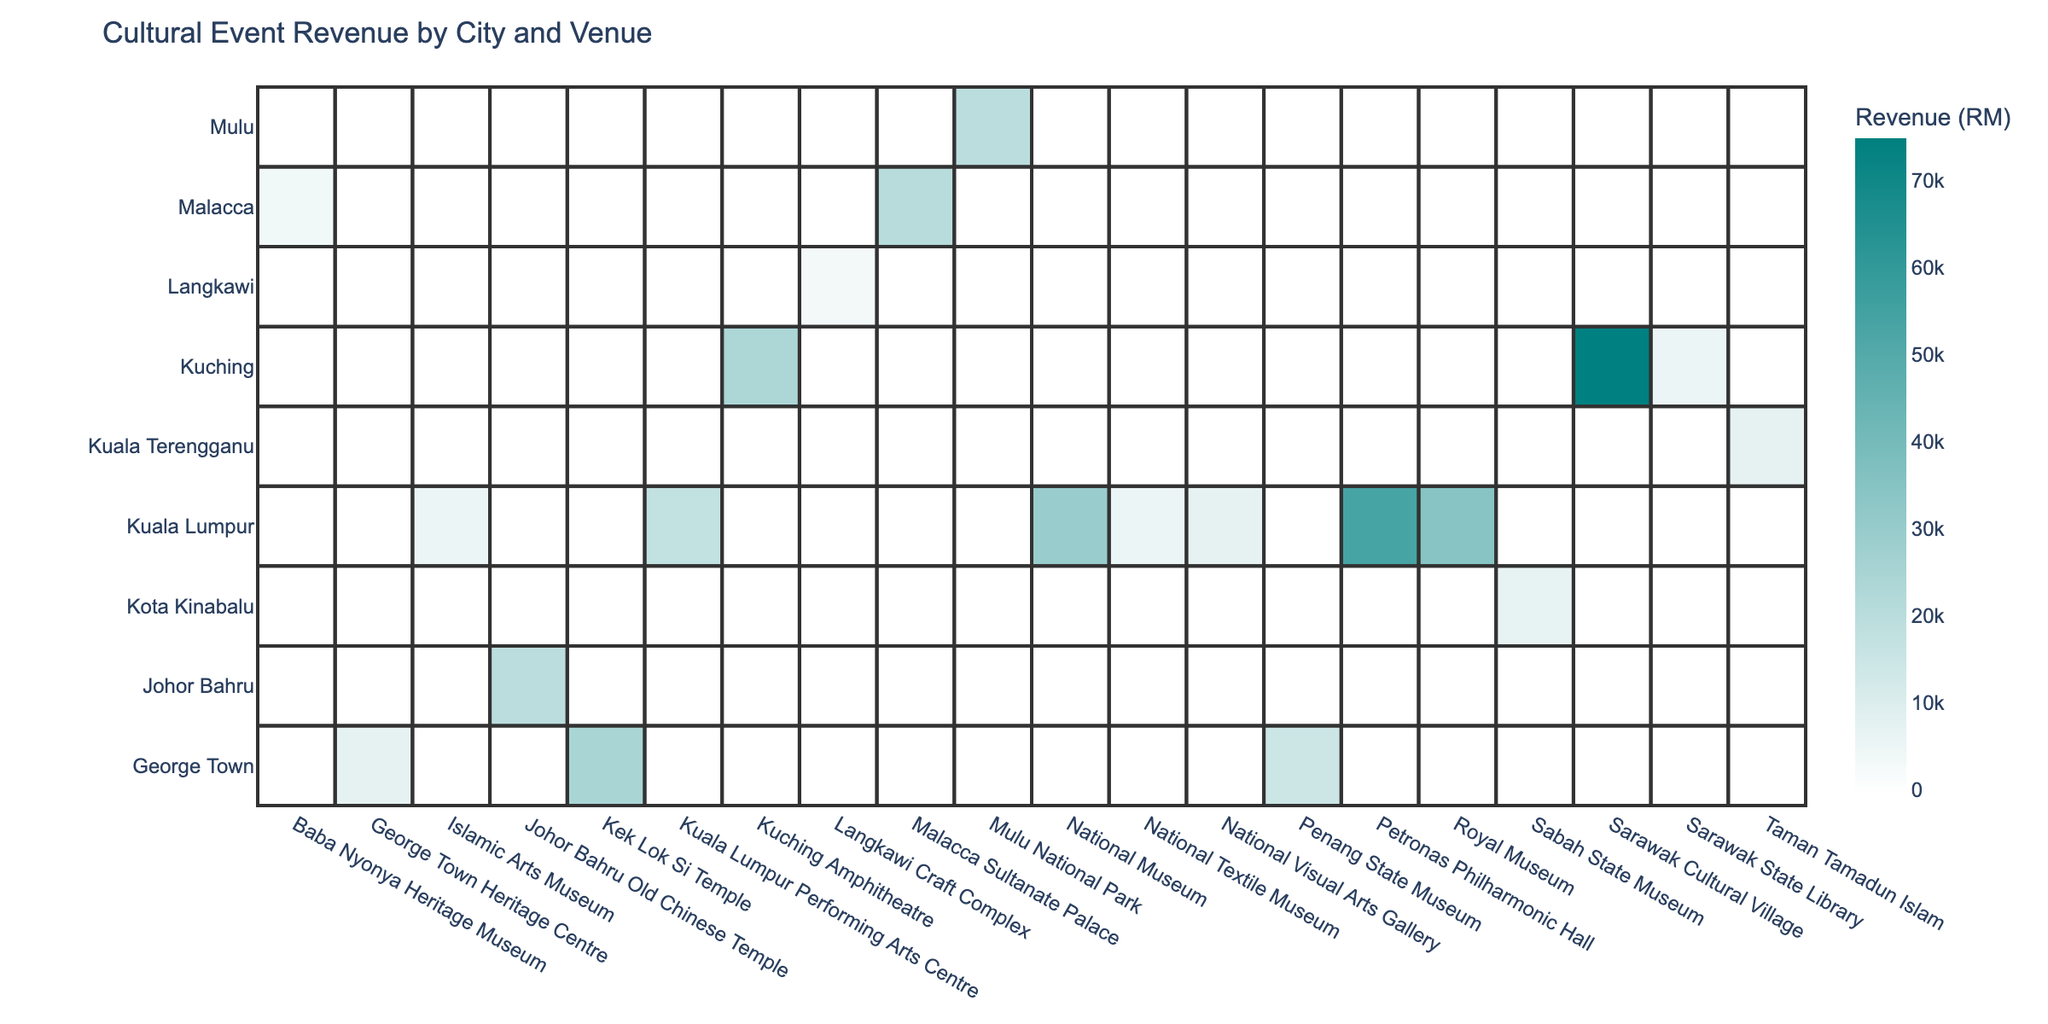What is the total revenue generated by the Sarawak Cultural Village? From the table, the revenue for the Sarawak Cultural Village from the Gawai Festival Celebration is listed as RM 75,000. Therefore, the total revenue generated by the Sarawak Cultural Village is RM 75,000.
Answer: RM 75,000 Which venue in Kuala Lumpur had the highest ticket sales? The venues in Kuala Lumpur and their corresponding ticket sales are: National Museum (1200), Islamic Arts Museum (150), Petronas Philharmonic Hall (900), and Kuala Lumpur Performing Arts Centre (400). The highest ticket sales are from the National Museum with 1200 tickets sold.
Answer: National Museum Was there any event in Johor Bahru that generated more than RM 20,000 in revenue? The event in Johor Bahru was the Lunar New Year Festival, which generated RM 20,000. Since we are looking for events that generated more than RM 20,000, the answer is no.
Answer: No What is the revenue difference between the Islamic Arts Museum and the National Textile Museum? The revenue for the Islamic Arts Museum from the Calligraphy Workshop is RM 6,000, while the revenue for the National Textile Museum from the Batik Making Workshop is RM 6,000 as well. The difference is RM 6,000 - RM 6,000 = RM 0. Therefore, there is no revenue difference between the two venues.
Answer: RM 0 Which city had the lowest total revenue from cultural events? To find the city with the lowest total revenue, we sum the revenues for each city: Kuala Lumpur (30,000 + 6,000 + 54,000 + 18,000 + 0 = 108,000), Kuching (24,000 + 75,000 + 6,000 = 105,000), George Town (7,500 + 15,000 + 25,000 = 47,500), Kota Kinabalu (7,000), Malacca (21,000 + 4,000 = 25,000), Johor Bahru (20,000), Kuala Terengganu (7,500), and Mulu (20,000). The city with the lowest total revenue is Kota Kinabalu with RM 7,000.
Answer: Kota Kinabalu Which event in George Town had the highest revenue? The events in George Town with their revenues are: Cultural Film Festival (RM 7,500), Peranakan Culture Exhibition (RM 15,000), and Vesak Day Celebration (RM 25,000). The event with the highest revenue is the Vesak Day Celebration.
Answer: Vesak Day Celebration 